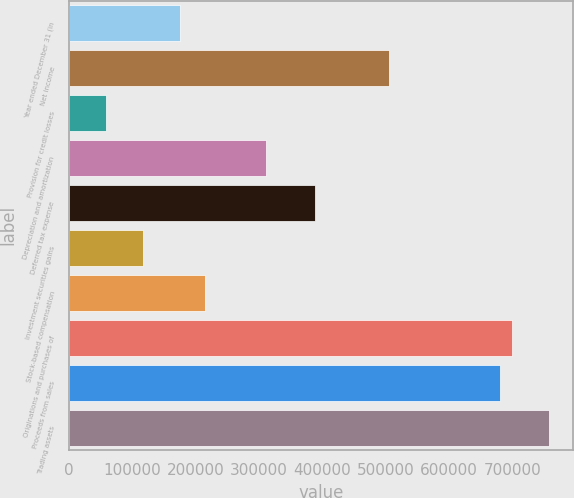<chart> <loc_0><loc_0><loc_500><loc_500><bar_chart><fcel>Year ended December 31 (in<fcel>Net income<fcel>Provision for credit losses<fcel>Depreciation and amortization<fcel>Deferred tax expense<fcel>Investment securities gains<fcel>Stock-based compensation<fcel>Originations and purchases of<fcel>Proceeds from sales<fcel>Trading assets<nl><fcel>174940<fcel>505125<fcel>58404.8<fcel>310899<fcel>388589<fcel>116673<fcel>213786<fcel>699351<fcel>679928<fcel>757618<nl></chart> 